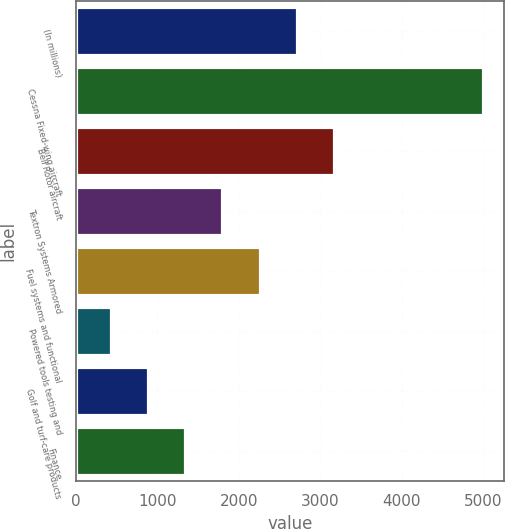Convert chart to OTSL. <chart><loc_0><loc_0><loc_500><loc_500><bar_chart><fcel>(In millions)<fcel>Cessna Fixed-wing aircraft<fcel>Bell Rotor aircraft<fcel>Textron Systems Armored<fcel>Fuel systems and functional<fcel>Powered tools testing and<fcel>Golf and turf-care products<fcel>Finance<nl><fcel>2713<fcel>5000<fcel>3170.4<fcel>1798.2<fcel>2255.6<fcel>426<fcel>883.4<fcel>1340.8<nl></chart> 